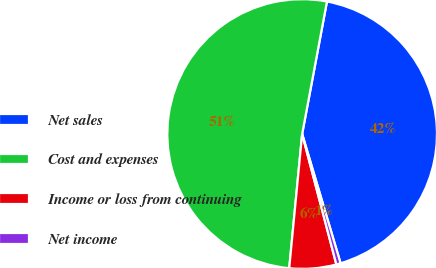<chart> <loc_0><loc_0><loc_500><loc_500><pie_chart><fcel>Net sales<fcel>Cost and expenses<fcel>Income or loss from continuing<fcel>Net income<nl><fcel>42.45%<fcel>51.42%<fcel>5.61%<fcel>0.52%<nl></chart> 